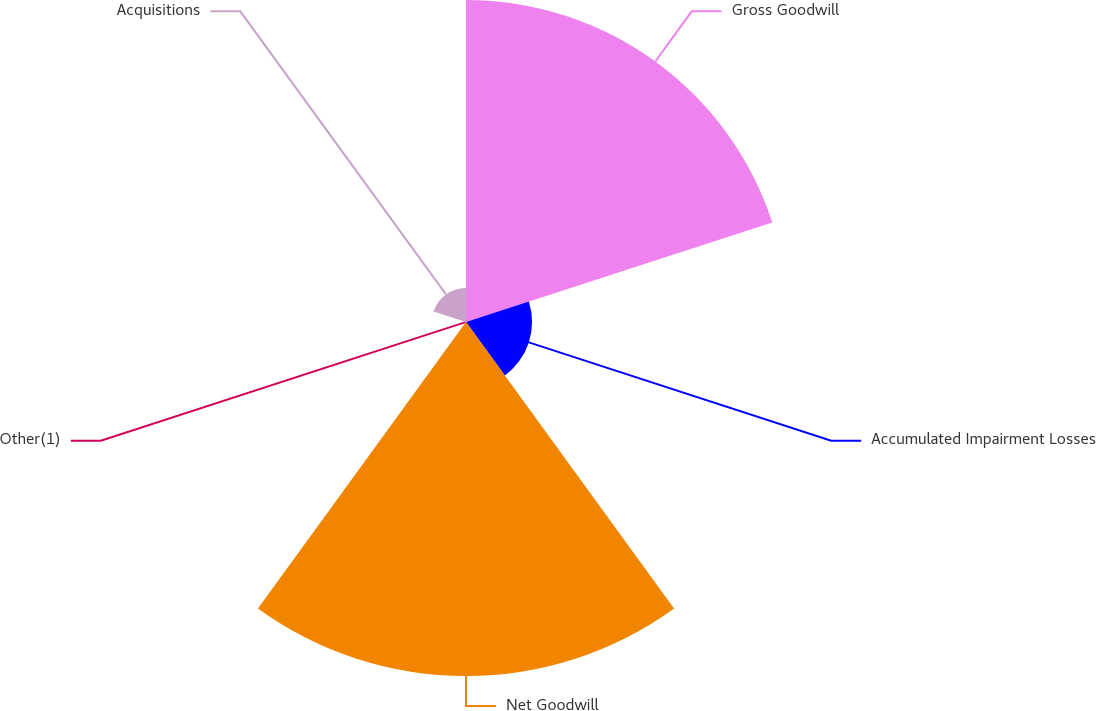Convert chart. <chart><loc_0><loc_0><loc_500><loc_500><pie_chart><fcel>Gross Goodwill<fcel>Accumulated Impairment Losses<fcel>Net Goodwill<fcel>Other(1)<fcel>Acquisitions<nl><fcel>41.38%<fcel>8.49%<fcel>45.49%<fcel>0.26%<fcel>4.38%<nl></chart> 